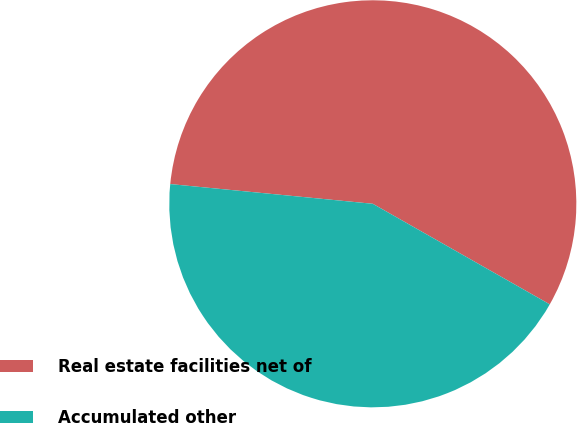Convert chart. <chart><loc_0><loc_0><loc_500><loc_500><pie_chart><fcel>Real estate facilities net of<fcel>Accumulated other<nl><fcel>56.68%<fcel>43.32%<nl></chart> 